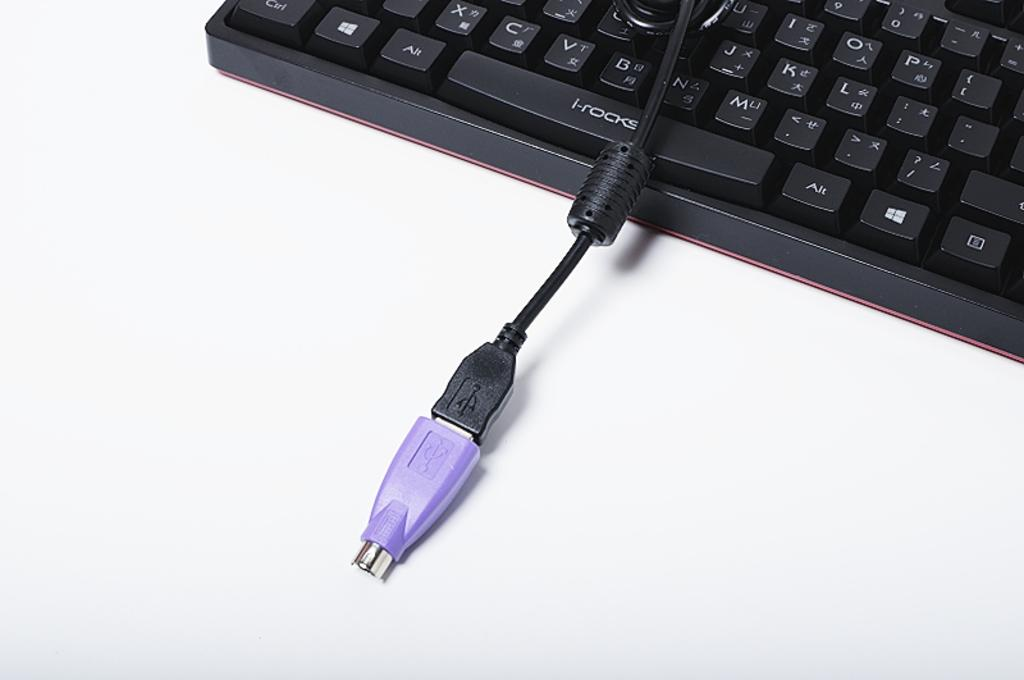<image>
Give a short and clear explanation of the subsequent image. A keyboard with I-Rocks on the space bar. 